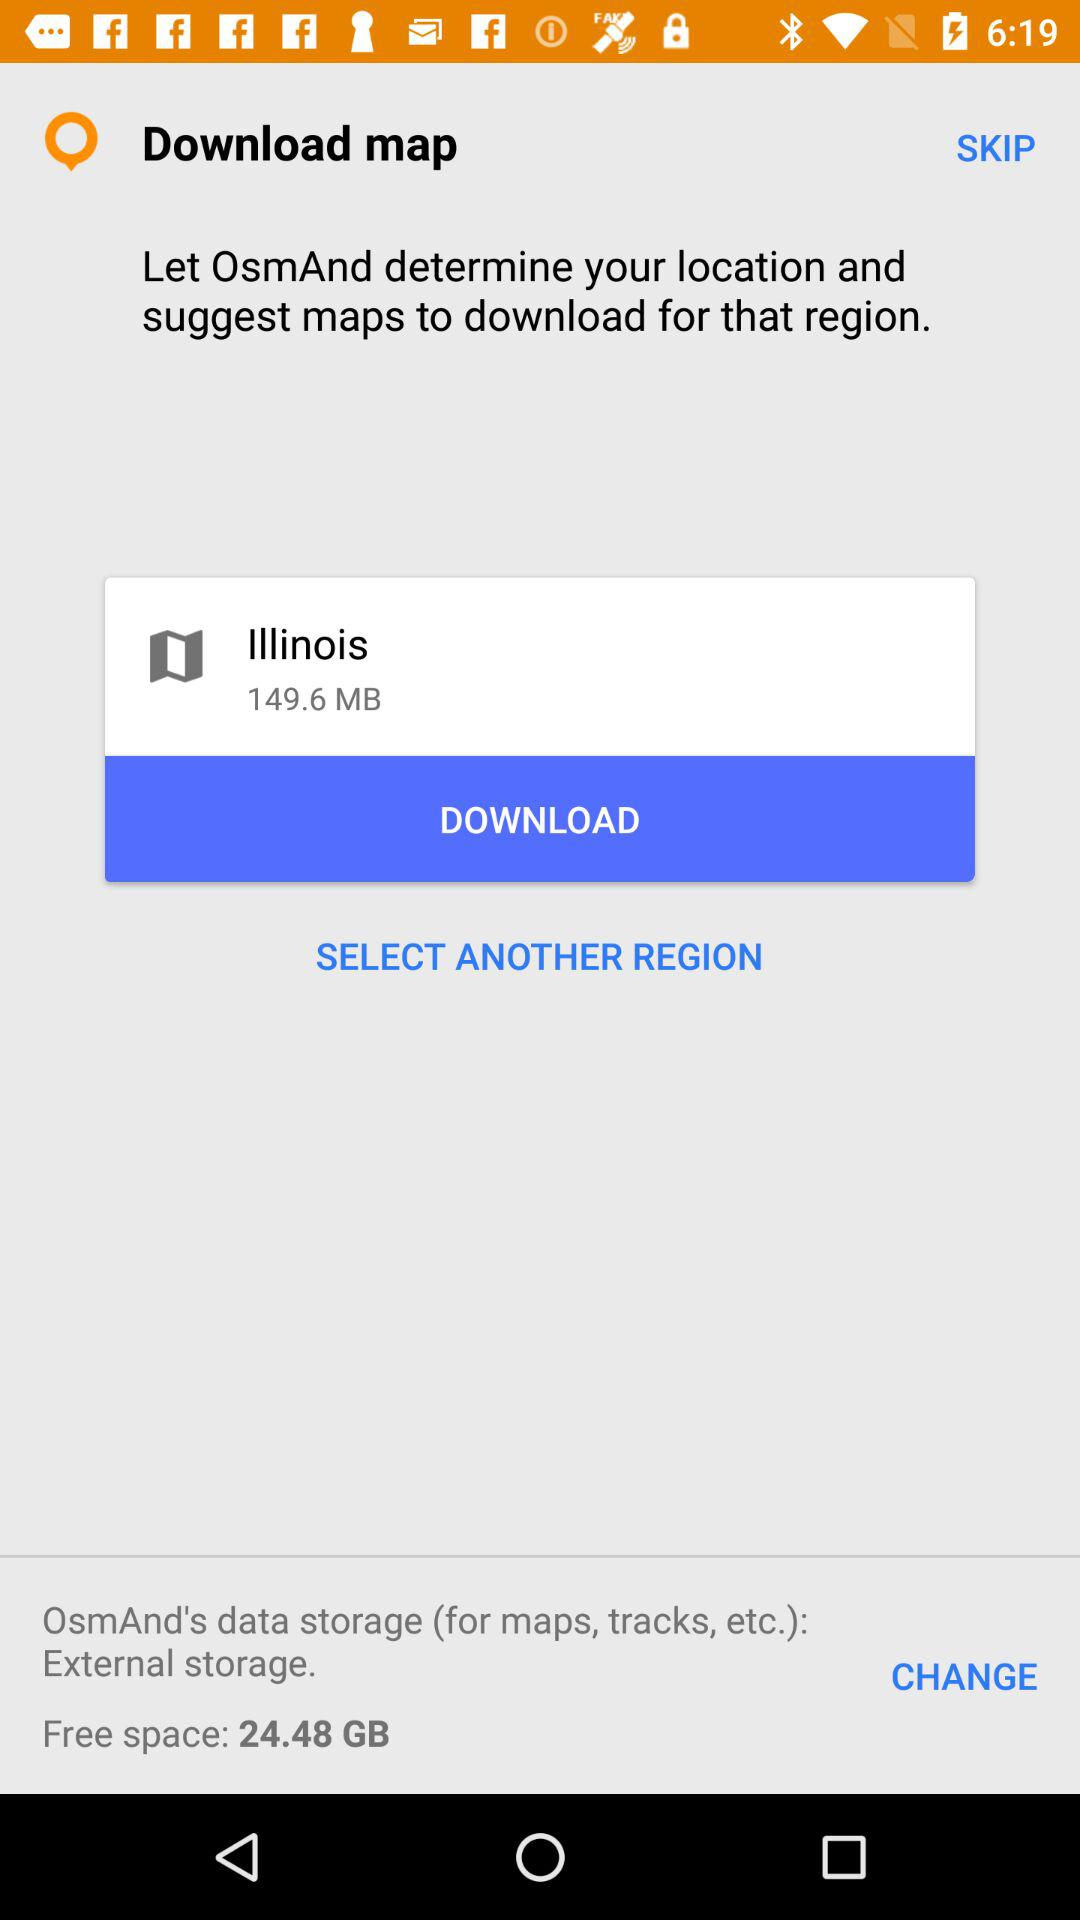How much free space is available on the device?
Answer the question using a single word or phrase. 24.48 GB 